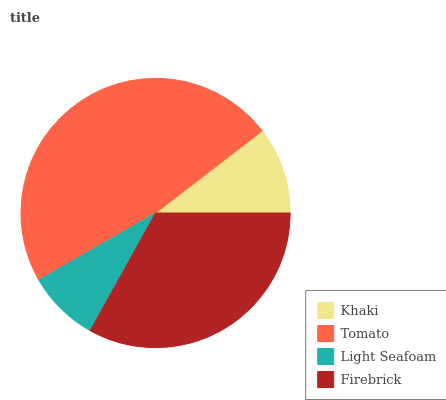Is Light Seafoam the minimum?
Answer yes or no. Yes. Is Tomato the maximum?
Answer yes or no. Yes. Is Tomato the minimum?
Answer yes or no. No. Is Light Seafoam the maximum?
Answer yes or no. No. Is Tomato greater than Light Seafoam?
Answer yes or no. Yes. Is Light Seafoam less than Tomato?
Answer yes or no. Yes. Is Light Seafoam greater than Tomato?
Answer yes or no. No. Is Tomato less than Light Seafoam?
Answer yes or no. No. Is Firebrick the high median?
Answer yes or no. Yes. Is Khaki the low median?
Answer yes or no. Yes. Is Light Seafoam the high median?
Answer yes or no. No. Is Light Seafoam the low median?
Answer yes or no. No. 